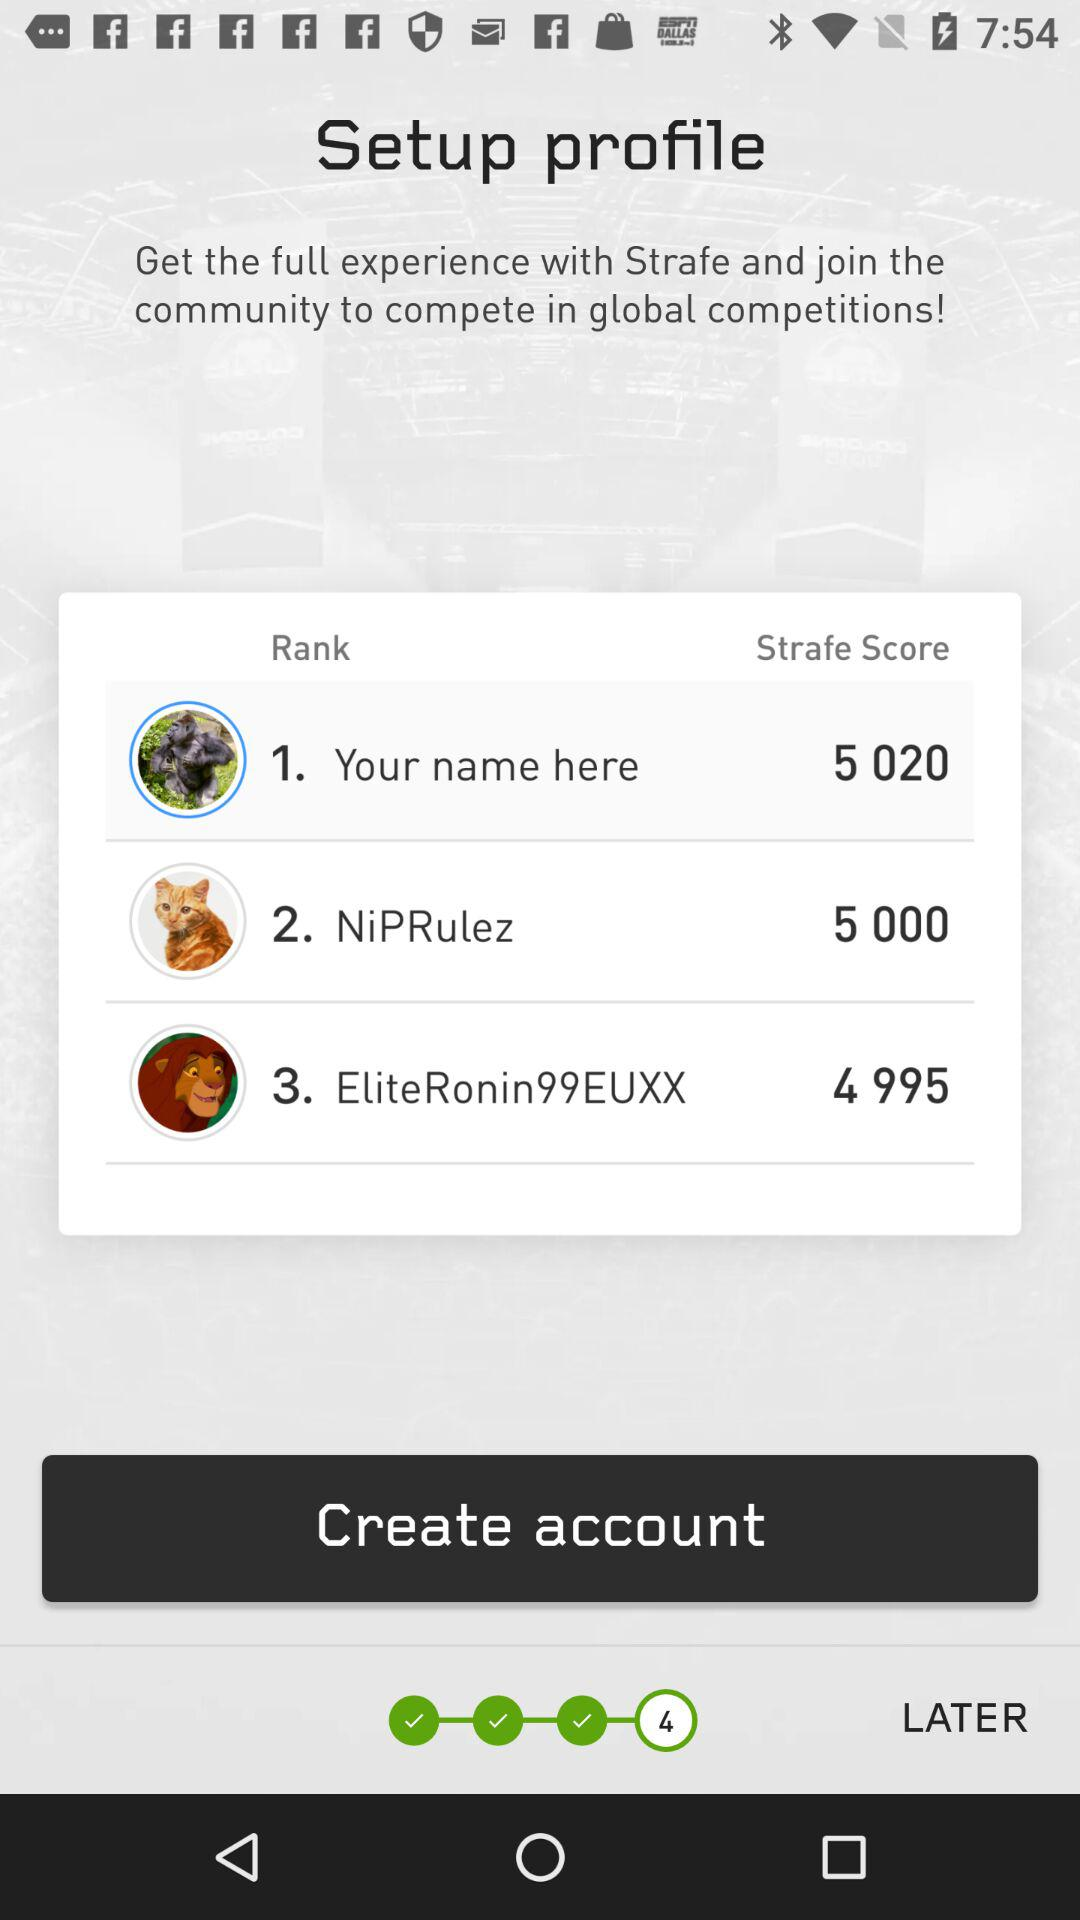How many players are in the top 3 of the Strafe score leaderboard?
Answer the question using a single word or phrase. 3 